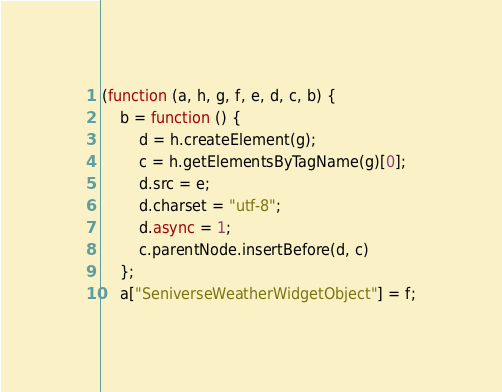<code> <loc_0><loc_0><loc_500><loc_500><_JavaScript_>(function (a, h, g, f, e, d, c, b) {
    b = function () {
        d = h.createElement(g);
        c = h.getElementsByTagName(g)[0];
        d.src = e;
        d.charset = "utf-8";
        d.async = 1;
        c.parentNode.insertBefore(d, c)
    };
    a["SeniverseWeatherWidgetObject"] = f;</code> 